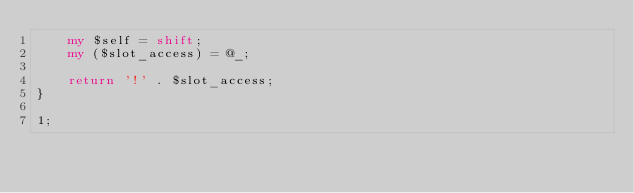<code> <loc_0><loc_0><loc_500><loc_500><_Perl_>    my $self = shift;
    my ($slot_access) = @_;

    return '!' . $slot_access;
}

1;
</code> 